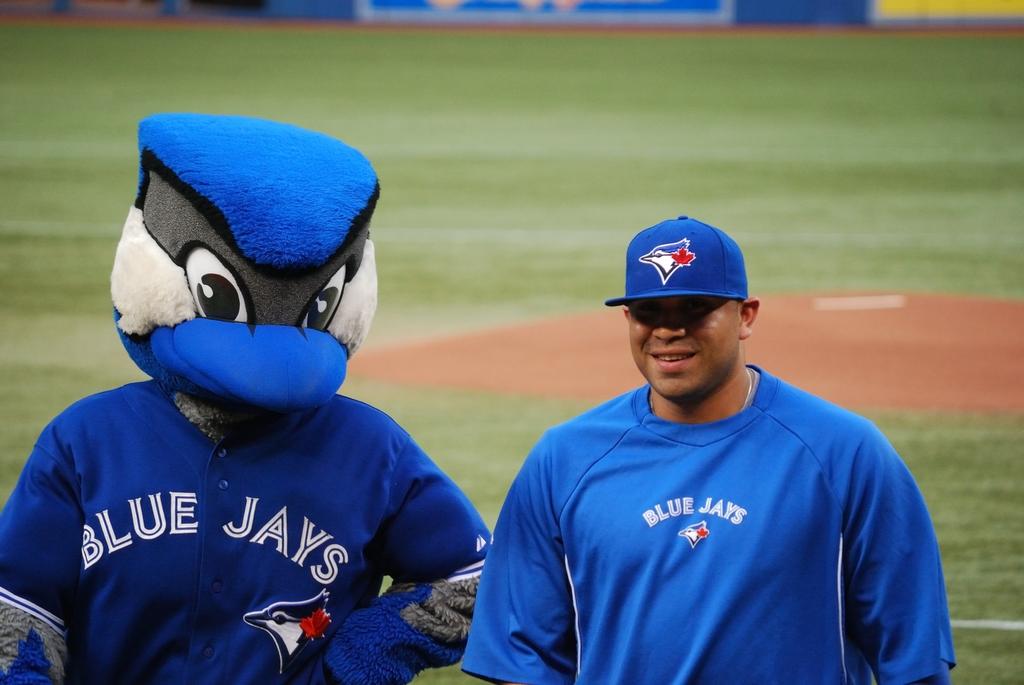What team does the mascot represent?
Your answer should be compact. Blue jays. What is the team?
Provide a succinct answer. Blue jays. 